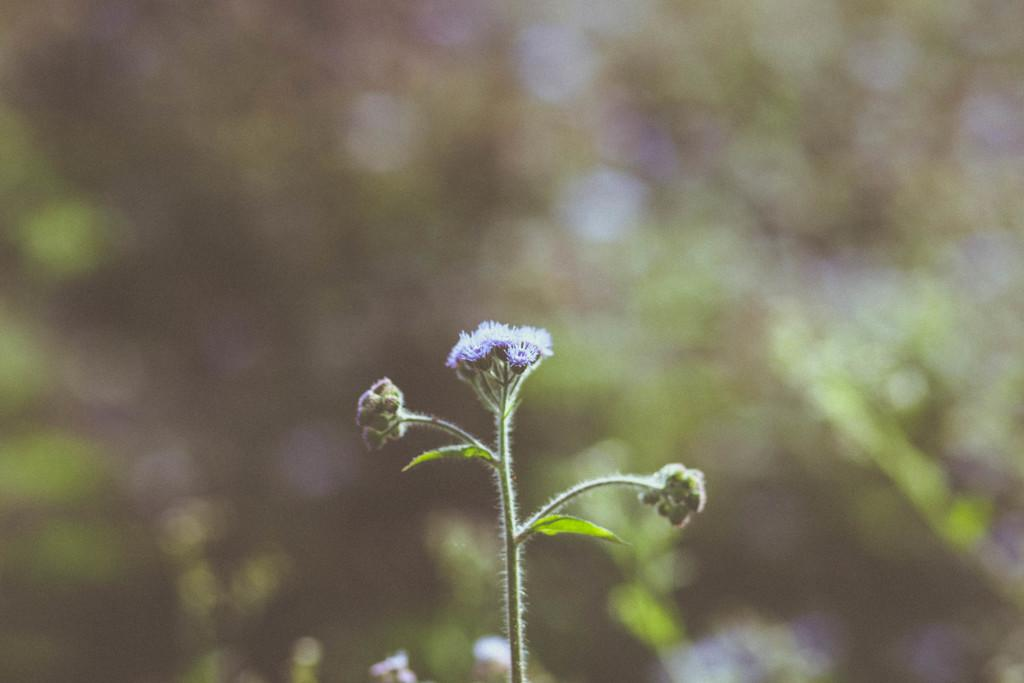What type of plants can be seen in the image? There are flowers and leaves in the image. Can you describe the background of the image? The background of the image is blurry. What type of distribution system is depicted in the image? There is no distribution system present in the image; it features flowers and leaves with a blurry background. What type of plane can be seen flying in the image? There is no plane present in the image. 